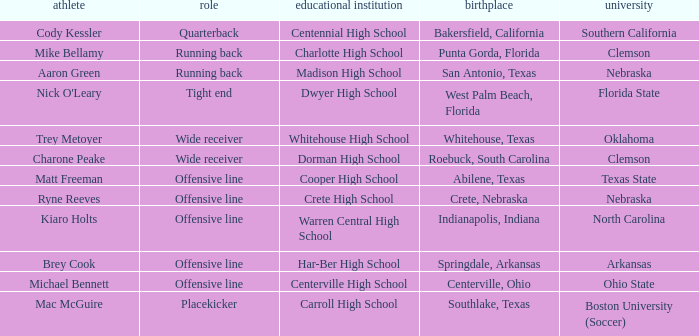What college did the placekicker go to? Boston University (Soccer). 